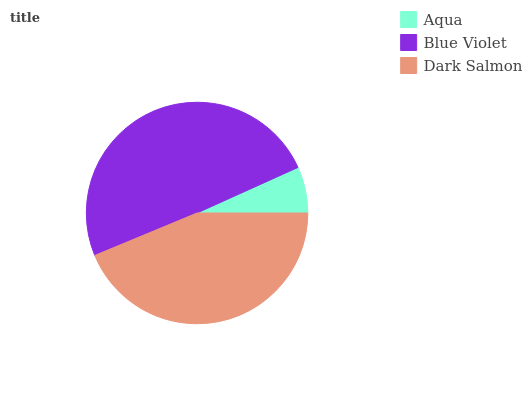Is Aqua the minimum?
Answer yes or no. Yes. Is Blue Violet the maximum?
Answer yes or no. Yes. Is Dark Salmon the minimum?
Answer yes or no. No. Is Dark Salmon the maximum?
Answer yes or no. No. Is Blue Violet greater than Dark Salmon?
Answer yes or no. Yes. Is Dark Salmon less than Blue Violet?
Answer yes or no. Yes. Is Dark Salmon greater than Blue Violet?
Answer yes or no. No. Is Blue Violet less than Dark Salmon?
Answer yes or no. No. Is Dark Salmon the high median?
Answer yes or no. Yes. Is Dark Salmon the low median?
Answer yes or no. Yes. Is Aqua the high median?
Answer yes or no. No. Is Blue Violet the low median?
Answer yes or no. No. 